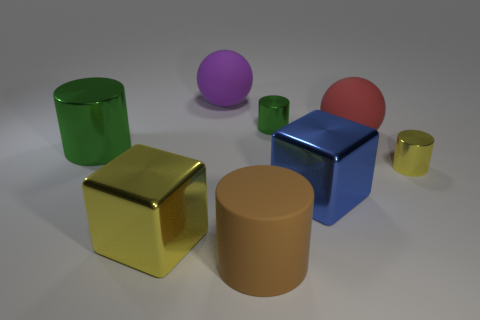Subtract all metal cylinders. How many cylinders are left? 1 Add 1 big purple rubber objects. How many objects exist? 9 Subtract all blocks. How many objects are left? 6 Subtract all green cylinders. How many cylinders are left? 2 Subtract 2 cylinders. How many cylinders are left? 2 Subtract all large metal spheres. Subtract all large matte balls. How many objects are left? 6 Add 4 big blue objects. How many big blue objects are left? 5 Add 6 tiny red metal objects. How many tiny red metal objects exist? 6 Subtract 1 red spheres. How many objects are left? 7 Subtract all gray cylinders. Subtract all gray balls. How many cylinders are left? 4 